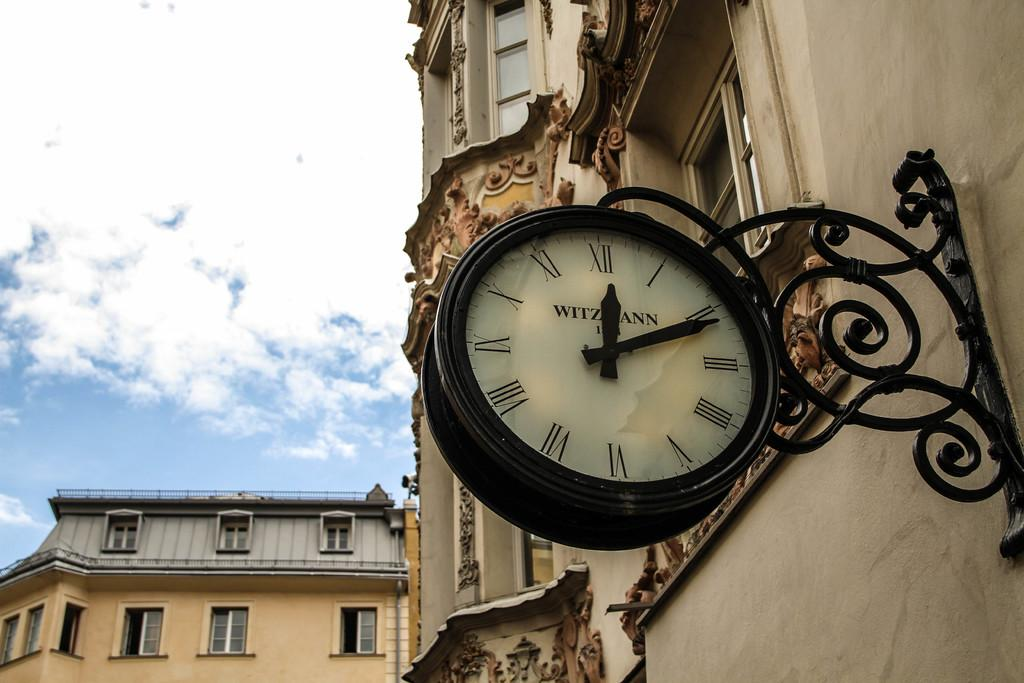<image>
Provide a brief description of the given image. Old clock on the wall showing 11 past noon 